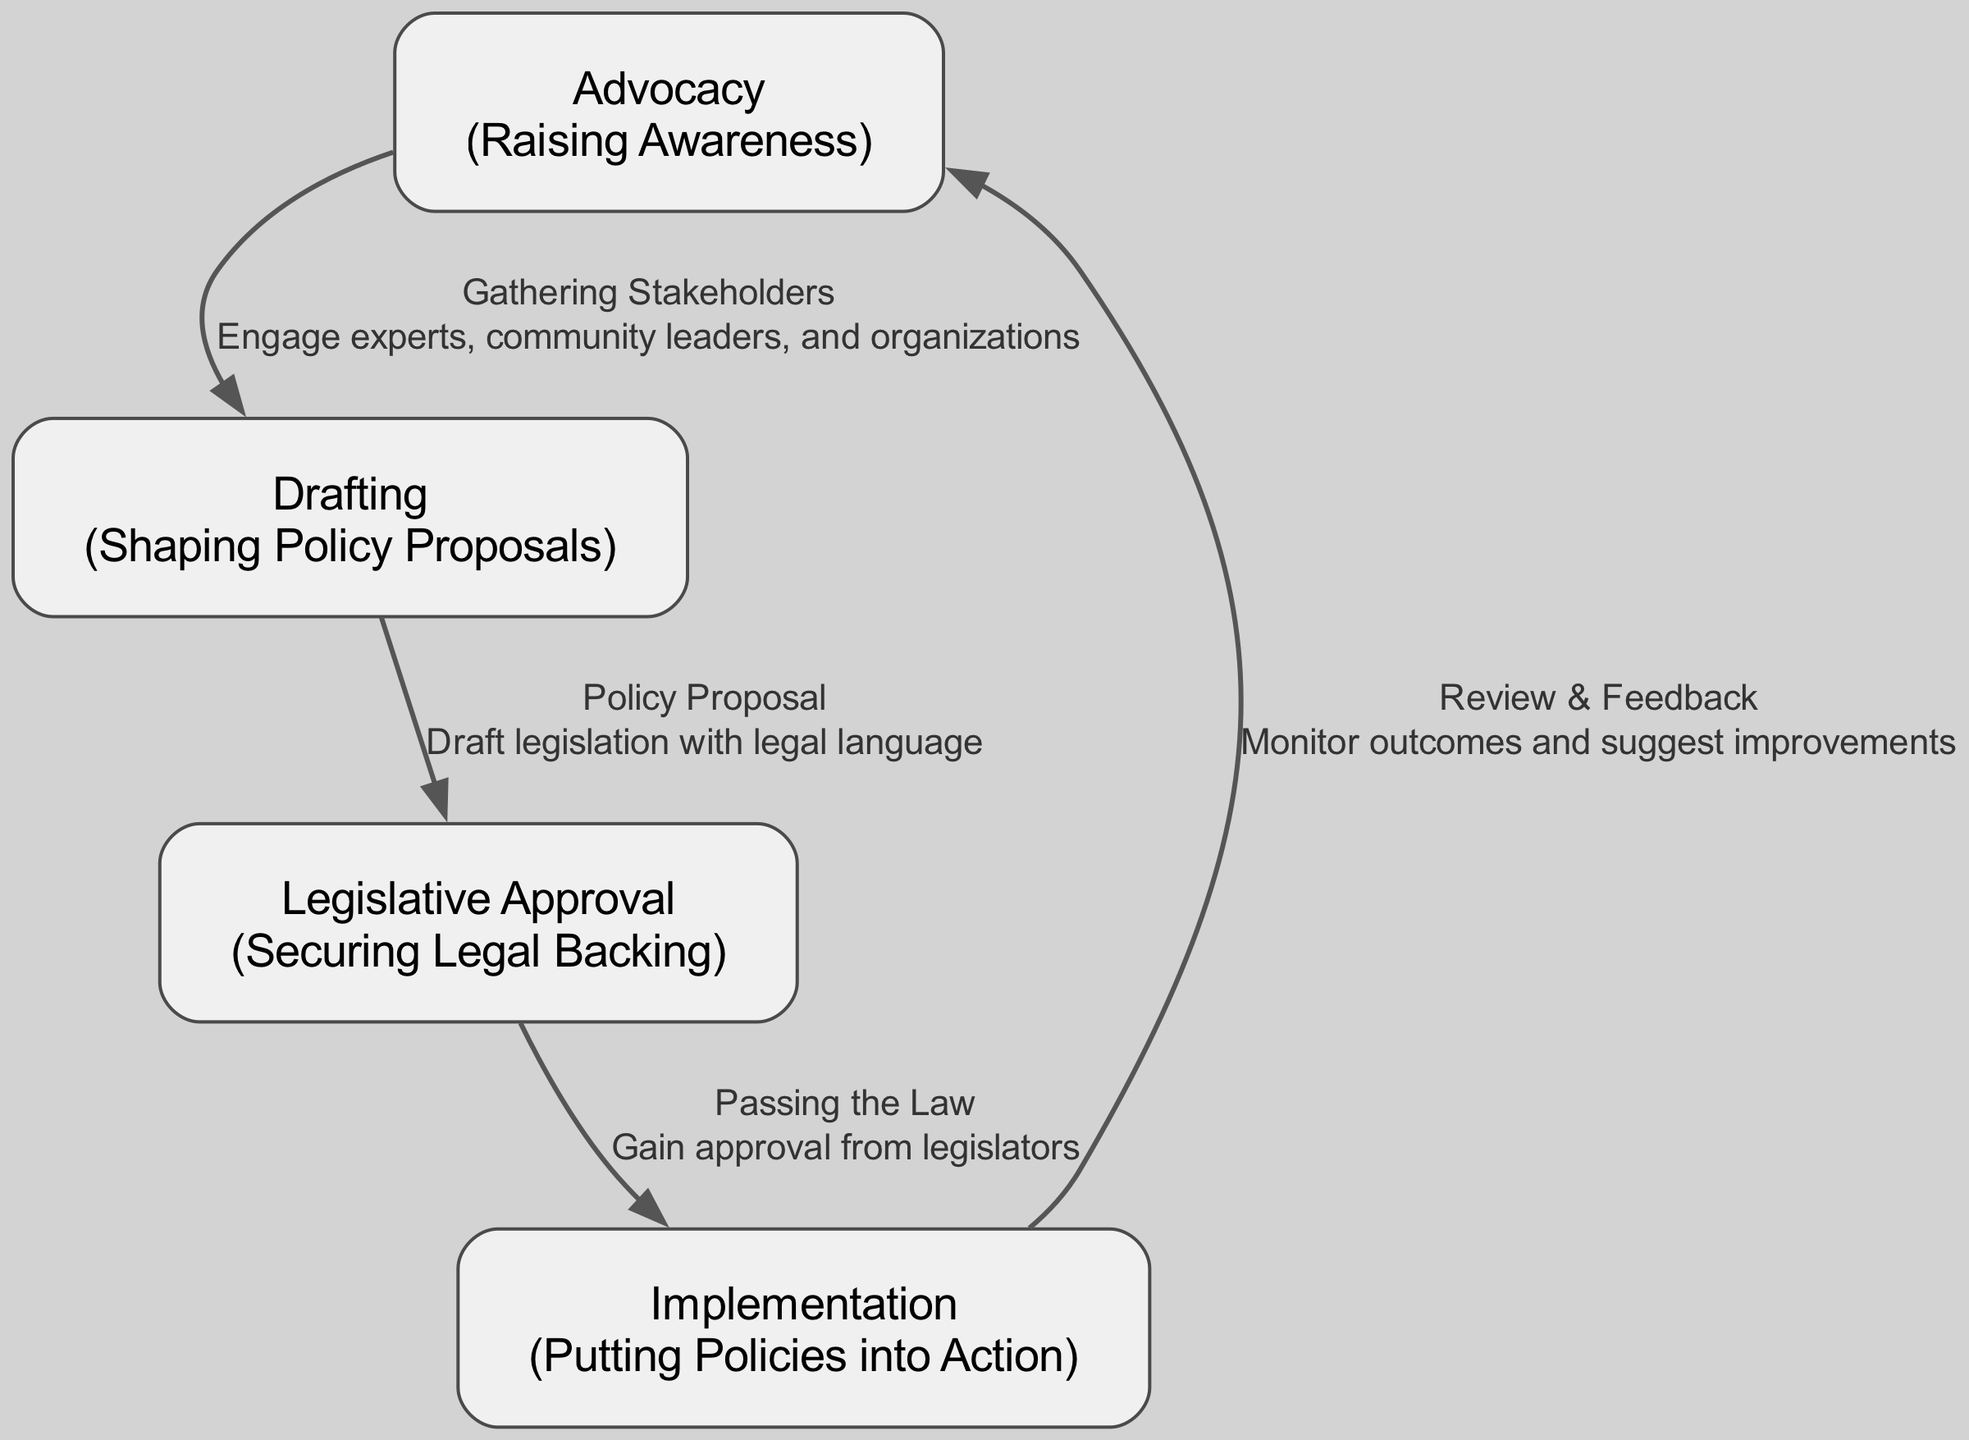What are the four stages in the policy lifecycle? The diagram lists four nodes: Advocacy, Drafting, Legislative Approval, and Implementation as the stages in the policy lifecycle.
Answer: Advocacy, Drafting, Legislative Approval, Implementation What is the relationship between Advocacy and Drafting? The diagram shows an edge connecting Advocacy to Drafting that is labeled "Gathering Stakeholders," indicating that advocacy involves engaging various stakeholders before drafting takes place.
Answer: Gathering Stakeholders How many edges are in the diagram? By counting each of the edges listed in the diagram, there are four connections: from Advocacy to Drafting, from Drafting to Legislative Approval, from Legislative Approval to Implementation, and from Implementation back to Advocacy.
Answer: 4 What is the purpose of the Implementation stage? The description of the Implementation node states: "Putting Policies into Action," signifying that this stage is focused on executing the policies that have been developed and approved.
Answer: Putting Policies into Action What happens after Legislative Approval? According to the flow of the diagram, after Legislative Approval, the next stage is Implementation, indicating that once a policy is approved, it moves to the phase where it is enacted.
Answer: Implementation What is reviewed after the Implementation stage? The diagram indicates that following Implementation, there is a review and feedback process, allowing for monitoring outcomes and suggesting improvements to the policies enacted.
Answer: Review & Feedback How does the process return to Advocacy? The flowchart indicates that after Implementation, the cycle returns to Advocacy through the Review & Feedback stage, implying that results from the implementation are used to inform and improve advocacy efforts.
Answer: Review & Feedback What is indicated by the edge labeled "Passing the Law"? The edge indicates that the Legislative Approval stage culminates in the action of passing the law, which means securing legal backing for the proposed policies supporting children who have experienced trauma.
Answer: Passing the Law 